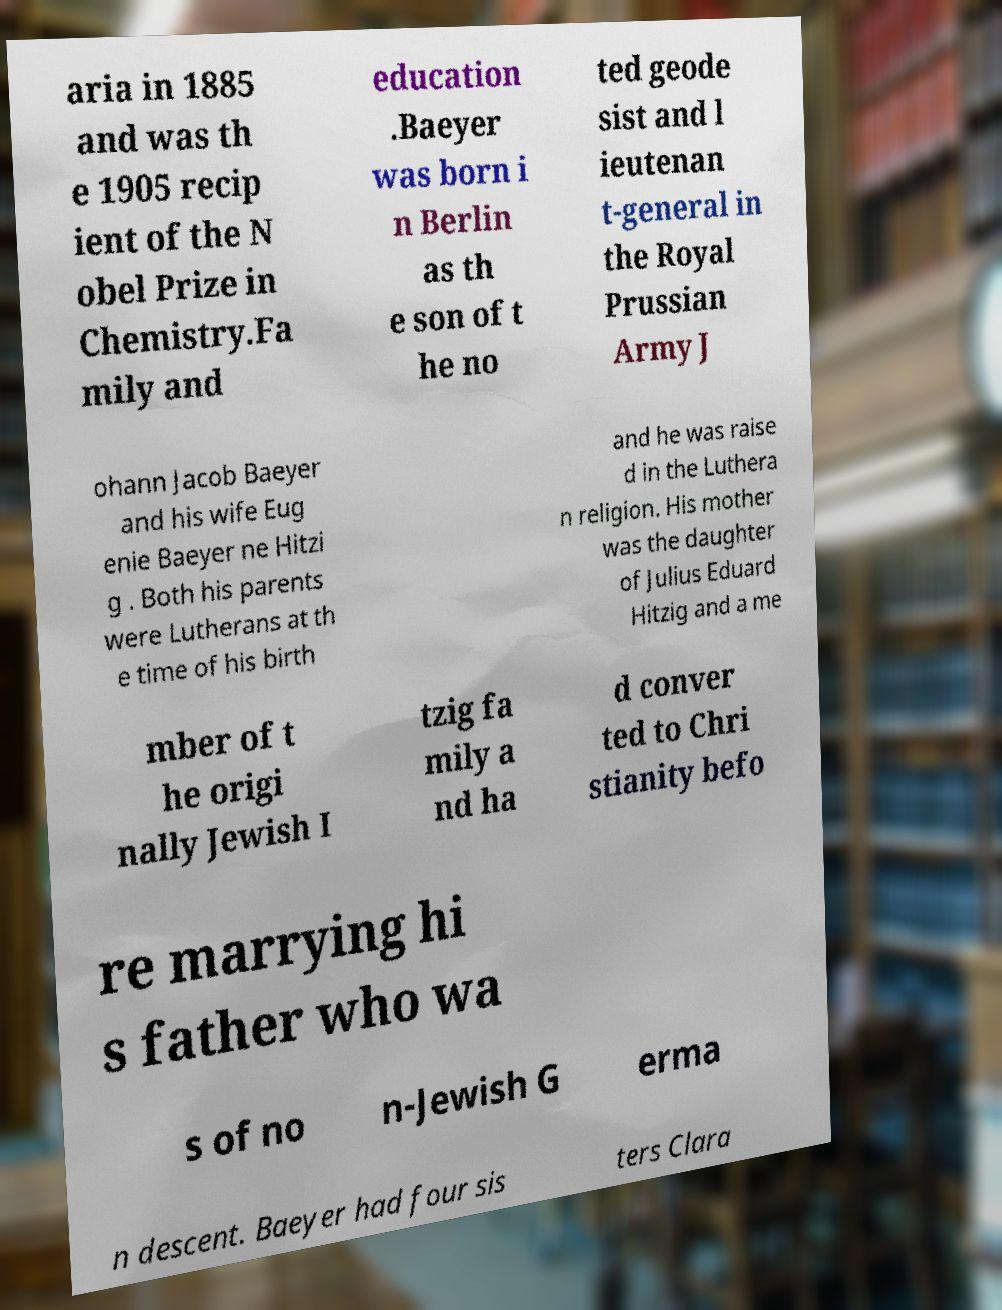For documentation purposes, I need the text within this image transcribed. Could you provide that? aria in 1885 and was th e 1905 recip ient of the N obel Prize in Chemistry.Fa mily and education .Baeyer was born i n Berlin as th e son of t he no ted geode sist and l ieutenan t-general in the Royal Prussian Army J ohann Jacob Baeyer and his wife Eug enie Baeyer ne Hitzi g . Both his parents were Lutherans at th e time of his birth and he was raise d in the Luthera n religion. His mother was the daughter of Julius Eduard Hitzig and a me mber of t he origi nally Jewish I tzig fa mily a nd ha d conver ted to Chri stianity befo re marrying hi s father who wa s of no n-Jewish G erma n descent. Baeyer had four sis ters Clara 